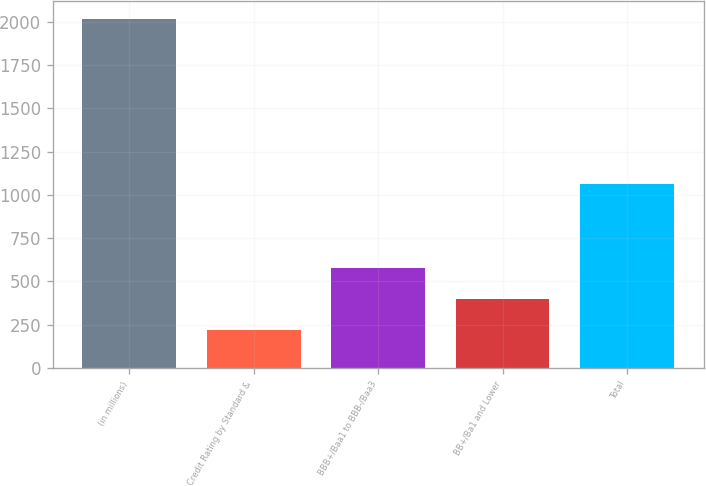Convert chart. <chart><loc_0><loc_0><loc_500><loc_500><bar_chart><fcel>(in millions)<fcel>Credit Rating by Standard &<fcel>BBB+/Baa1 to BBB-/Baa3<fcel>BB+/Ba1 and Lower<fcel>Total<nl><fcel>2016<fcel>218<fcel>577.6<fcel>397.8<fcel>1060<nl></chart> 